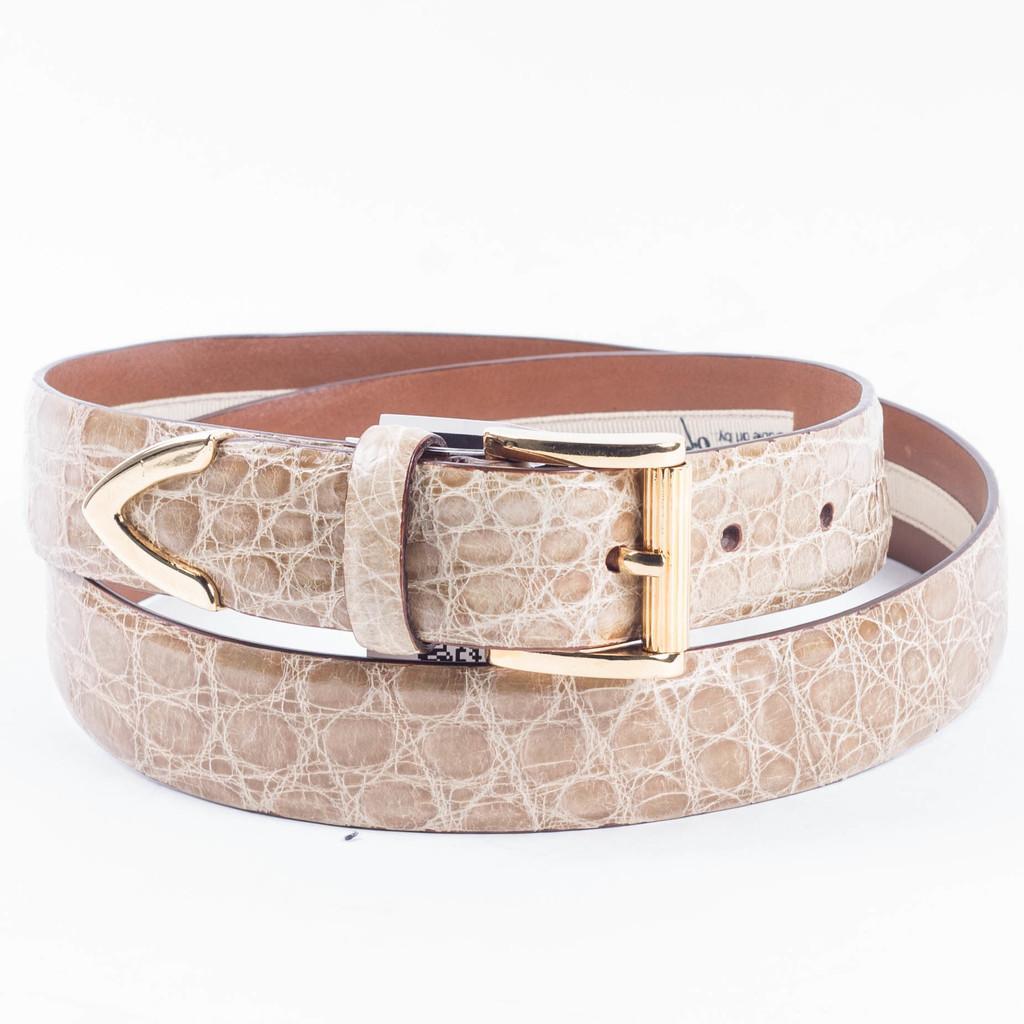Could you give a brief overview of what you see in this image? In this image there is a leather belt. Background is white in color. 